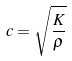Convert formula to latex. <formula><loc_0><loc_0><loc_500><loc_500>c = \sqrt { \frac { K } { \rho } }</formula> 